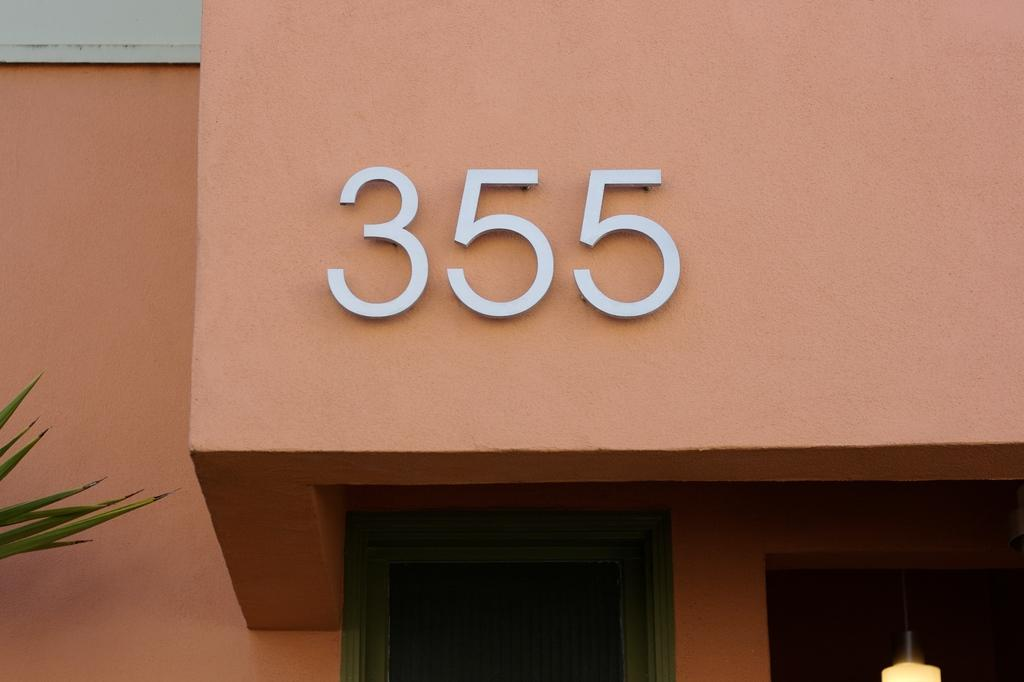What type of object is located on the left side of the image? There is a plant on the left side of the image. What architectural feature can be seen at the bottom of the image? There is a door at the bottom of the image. Is there any text or numbers visible in the image? Yes, the number "355" is written on the wall in the image. What type of berry is growing on the plant in the image? There is no berry growing on the plant in the image; it is a plant without any visible fruits. Is there any blood visible in the image? No, there is no blood visible in the image. 